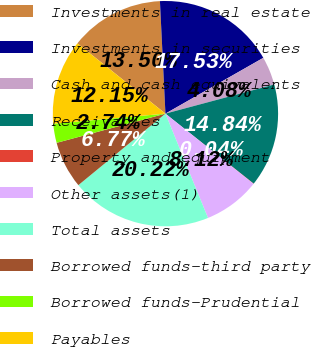Convert chart to OTSL. <chart><loc_0><loc_0><loc_500><loc_500><pie_chart><fcel>Investments in real estate<fcel>Investments in securities<fcel>Cash and cash equivalents<fcel>Receivables<fcel>Property and equipment<fcel>Other assets(1)<fcel>Total assets<fcel>Borrowed funds-third party<fcel>Borrowed funds-Prudential<fcel>Payables<nl><fcel>13.5%<fcel>17.53%<fcel>4.08%<fcel>14.84%<fcel>0.04%<fcel>8.12%<fcel>20.22%<fcel>6.77%<fcel>2.74%<fcel>12.15%<nl></chart> 